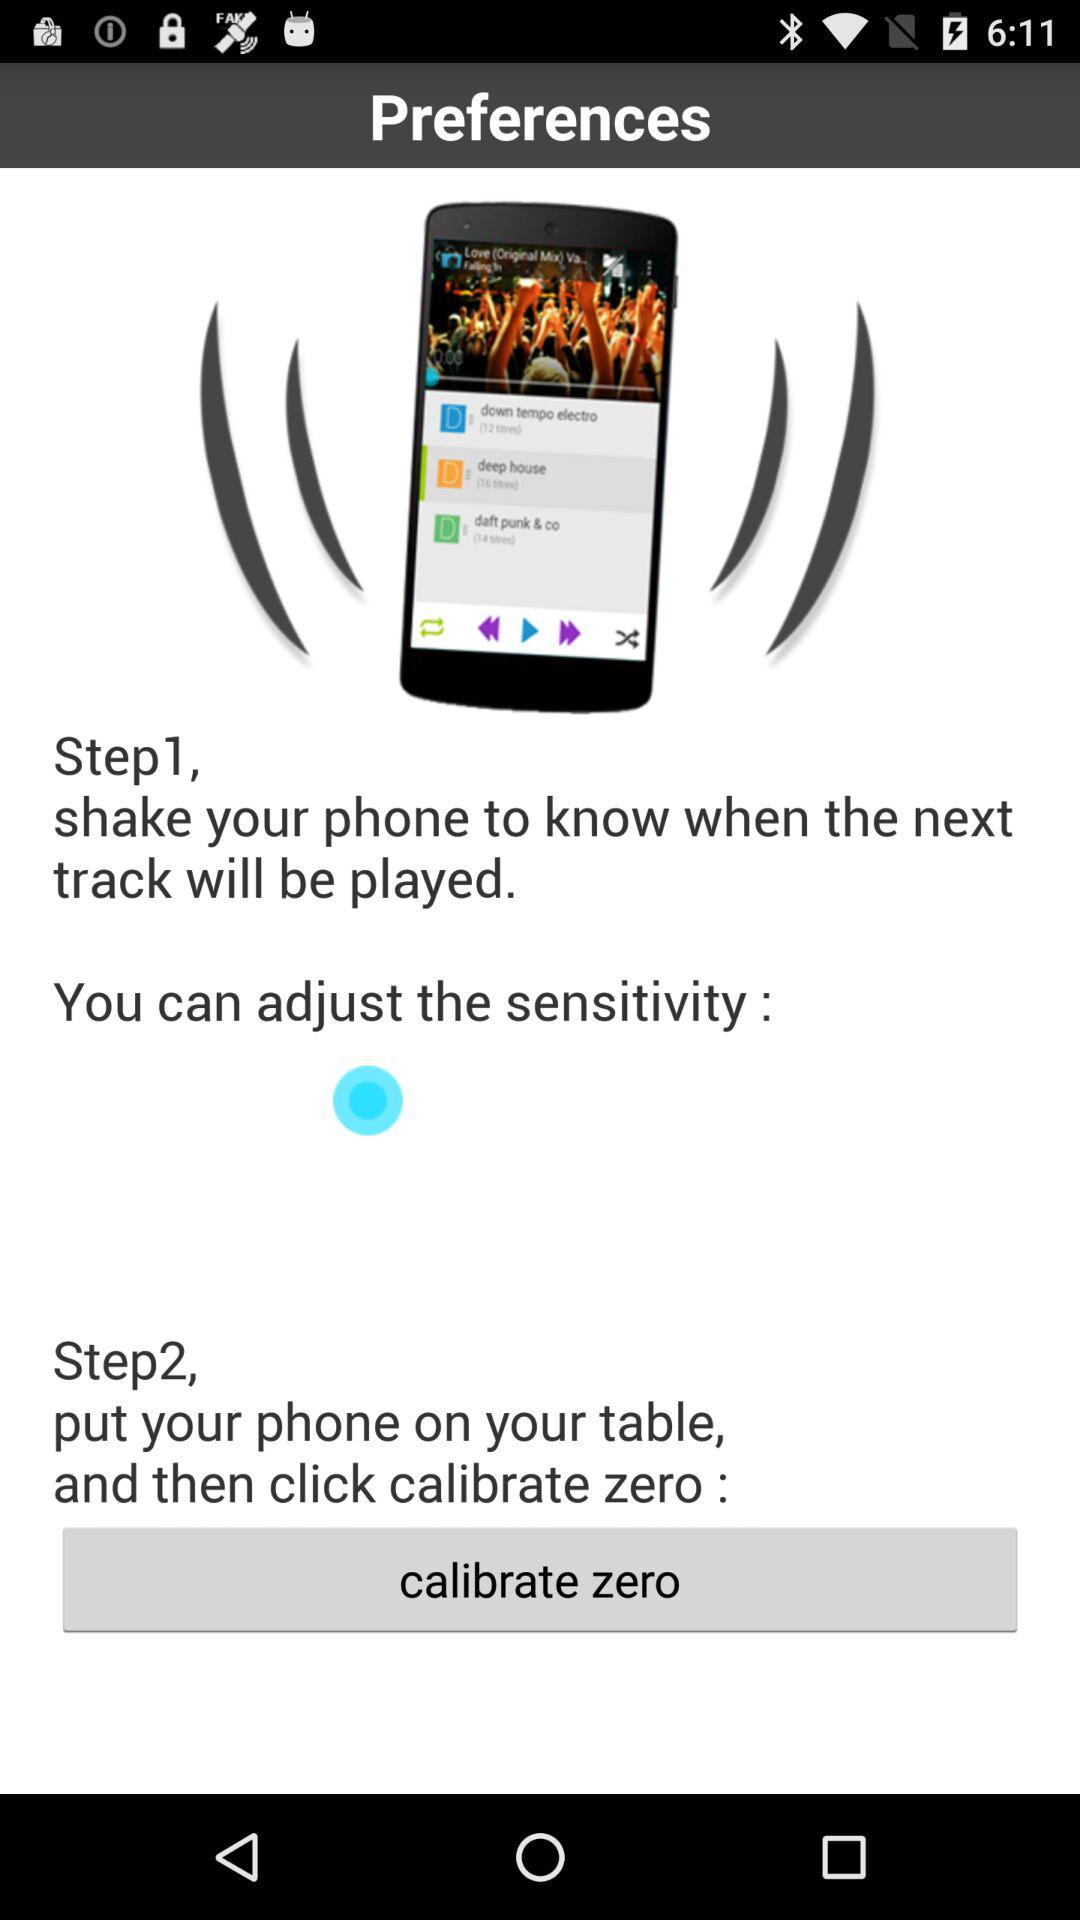What is step 2? Step 2 is to put your phone on the table and then click "calibrate zero". 